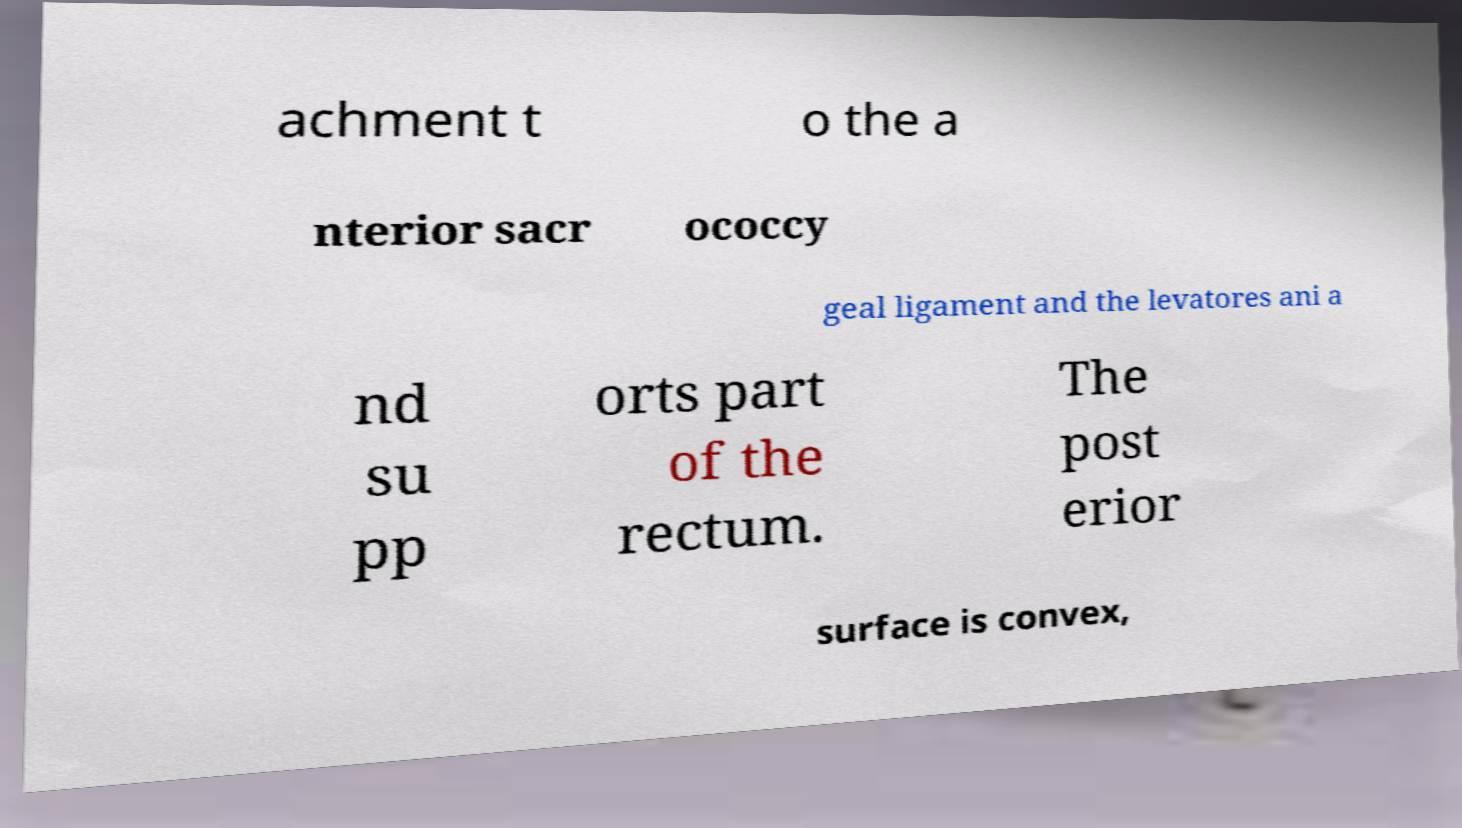Can you accurately transcribe the text from the provided image for me? achment t o the a nterior sacr ococcy geal ligament and the levatores ani a nd su pp orts part of the rectum. The post erior surface is convex, 